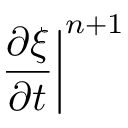<formula> <loc_0><loc_0><loc_500><loc_500>\frac { \partial \xi } { \partial t } \right | ^ { n + 1 }</formula> 